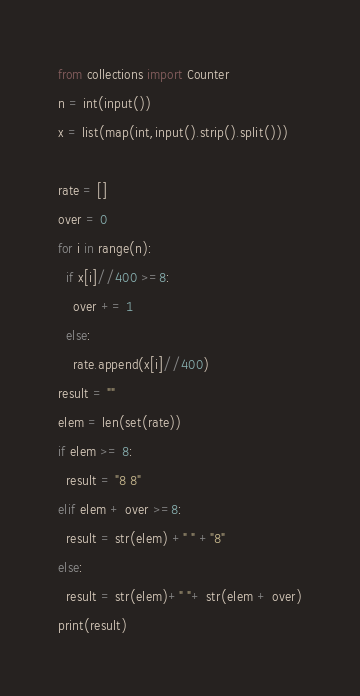<code> <loc_0><loc_0><loc_500><loc_500><_Python_>from collections import Counter
n = int(input())
x = list(map(int,input().strip().split()))

rate = []
over = 0
for i in range(n):
  if x[i]//400 >=8:
    over += 1
  else:
    rate.append(x[i]//400)
result = ""
elem = len(set(rate))
if elem >= 8:
  result = "8 8"
elif elem + over >=8:
  result = str(elem) +" " +"8"
else:
  result = str(elem)+" "+ str(elem + over)
print(result)</code> 